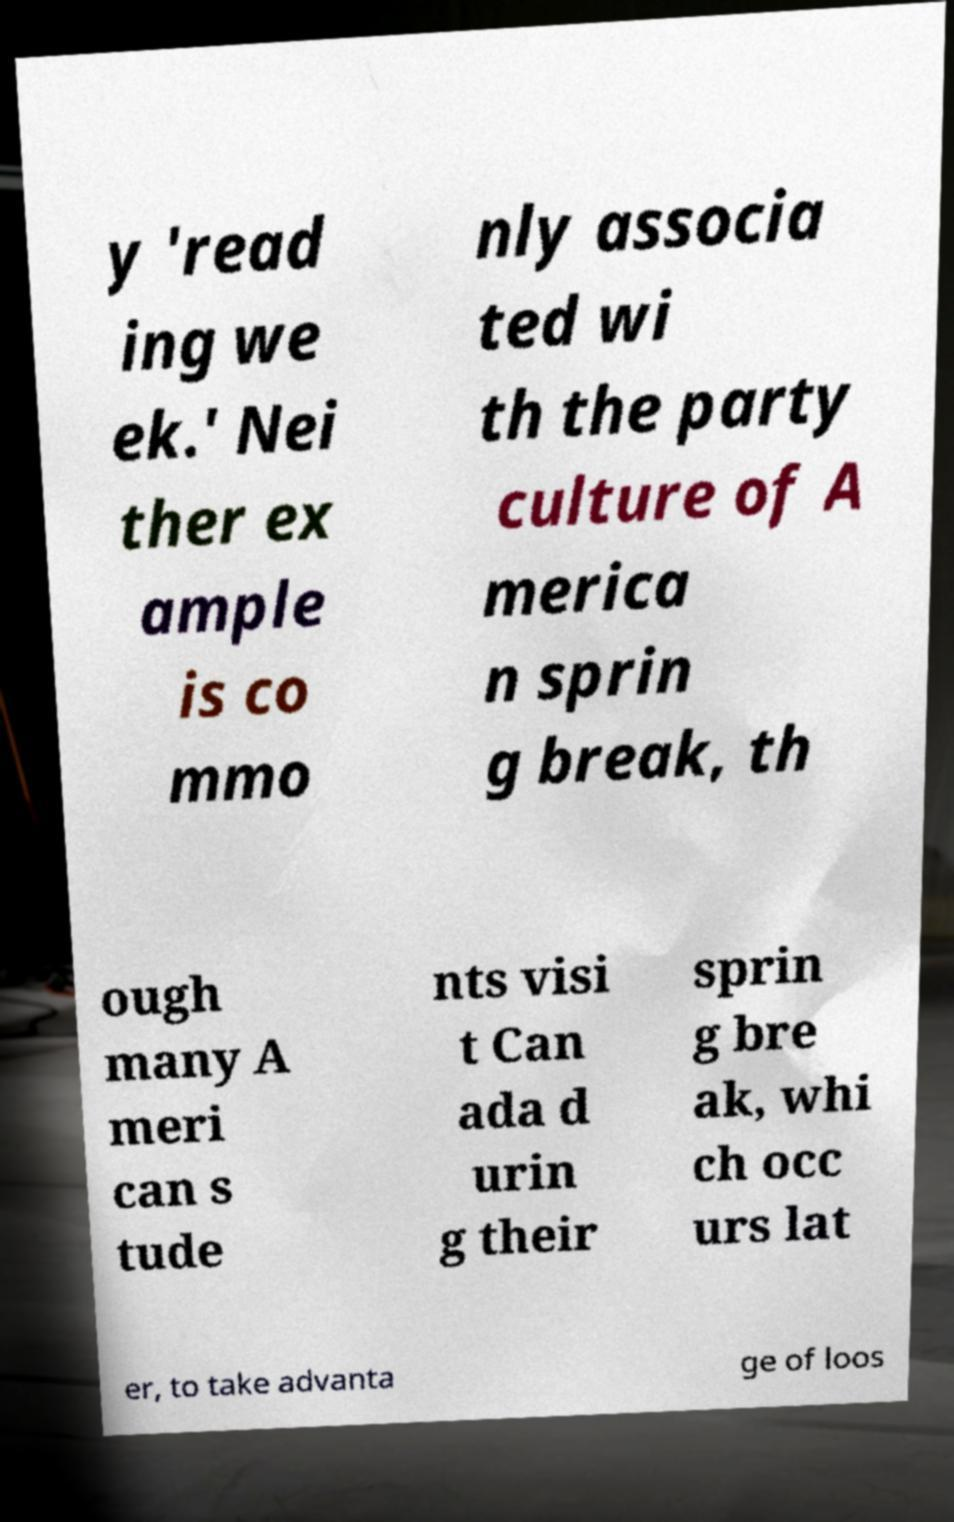Could you assist in decoding the text presented in this image and type it out clearly? y 'read ing we ek.' Nei ther ex ample is co mmo nly associa ted wi th the party culture of A merica n sprin g break, th ough many A meri can s tude nts visi t Can ada d urin g their sprin g bre ak, whi ch occ urs lat er, to take advanta ge of loos 